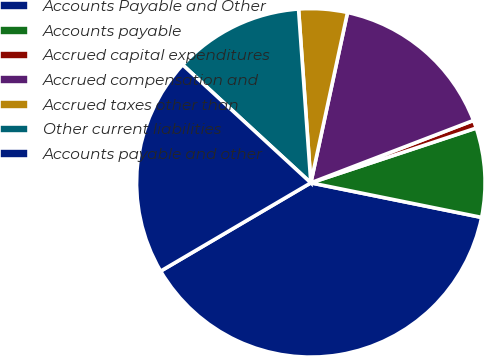Convert chart. <chart><loc_0><loc_0><loc_500><loc_500><pie_chart><fcel>Accounts Payable and Other<fcel>Accounts payable<fcel>Accrued capital expenditures<fcel>Accrued compensation and<fcel>Accrued taxes other than<fcel>Other current liabilities<fcel>Accounts payable and other<nl><fcel>38.36%<fcel>8.27%<fcel>0.74%<fcel>15.79%<fcel>4.5%<fcel>12.03%<fcel>20.3%<nl></chart> 